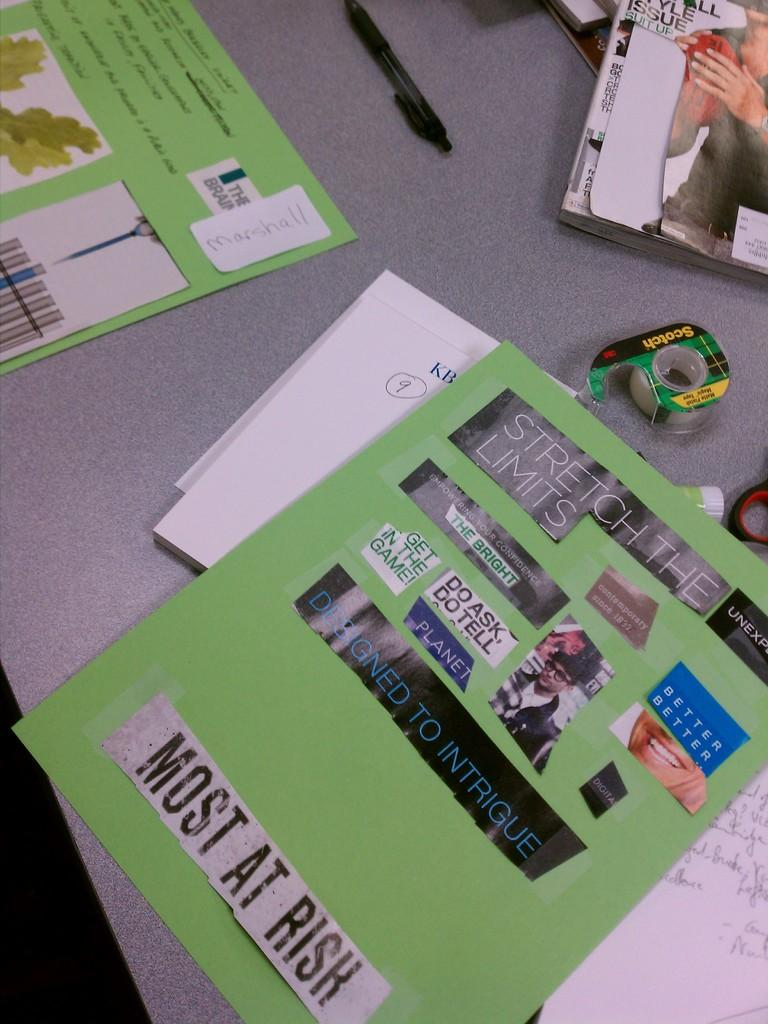<image>
Write a terse but informative summary of the picture. Several work projects, a magazine, pen and some Scotch tape sitting on a table. 